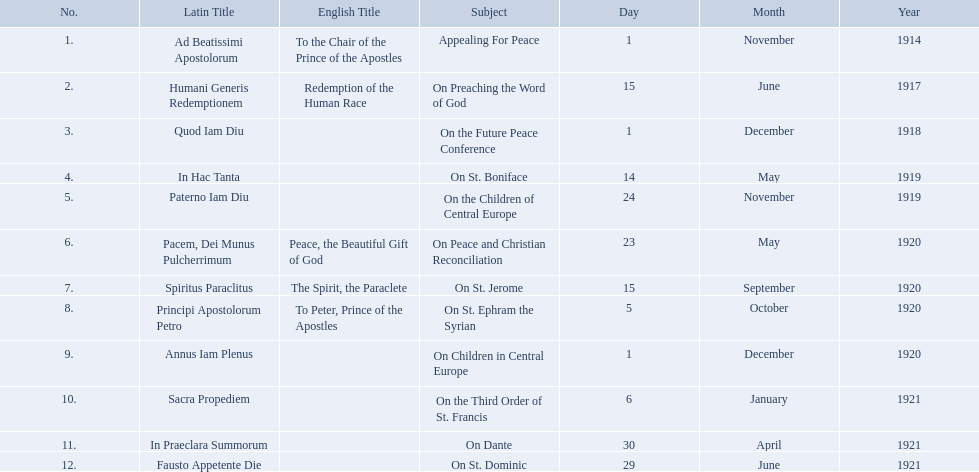What are all the subjects? Appealing For Peace, On Preaching the Word of God, On the Future Peace Conference, On St. Boniface, On the Children of Central Europe, On Peace and Christian Reconciliation, On St. Jerome, On St. Ephram the Syrian, On Children in Central Europe, On the Third Order of St. Francis, On Dante, On St. Dominic. Which occurred in 1920? On Peace and Christian Reconciliation, On St. Jerome, On St. Ephram the Syrian, On Children in Central Europe. Which occurred in may of that year? On Peace and Christian Reconciliation. 